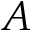Convert formula to latex. <formula><loc_0><loc_0><loc_500><loc_500>A</formula> 